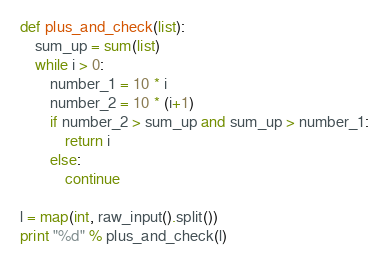Convert code to text. <code><loc_0><loc_0><loc_500><loc_500><_Python_>def plus_and_check(list):
    sum_up = sum(list)
    while i > 0:
        number_1 = 10 * i
        number_2 = 10 * (i+1)
        if number_2 > sum_up and sum_up > number_1:
            return i
        else:
            continue

l = map(int, raw_input().split())
print "%d" % plus_and_check(l)</code> 